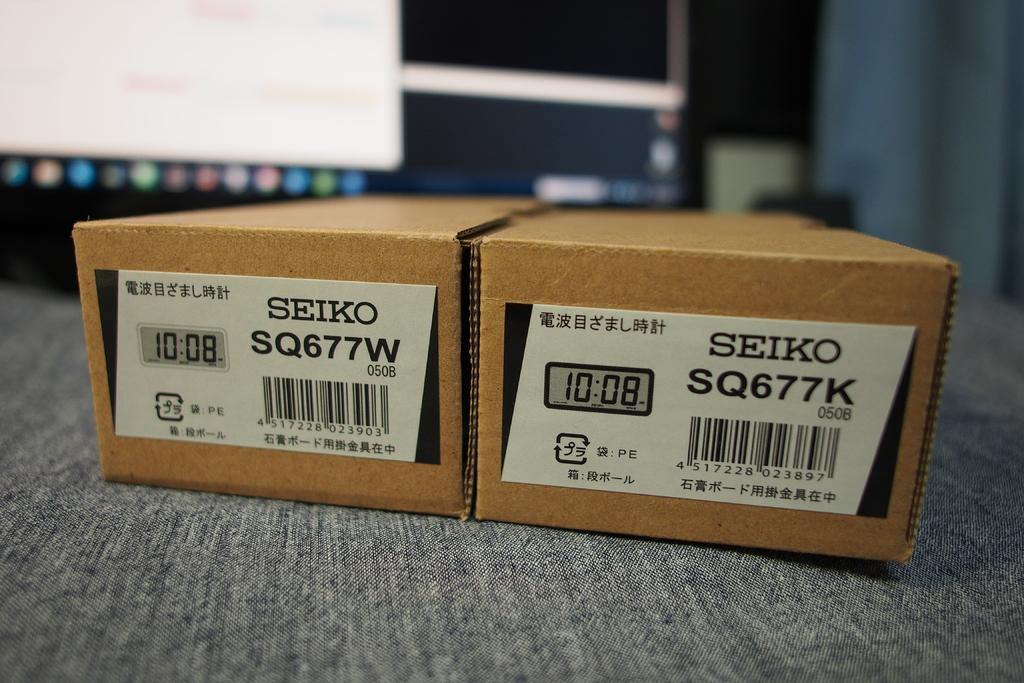<image>
Present a compact description of the photo's key features. two small boxes next to each other labeld 'seiko' 